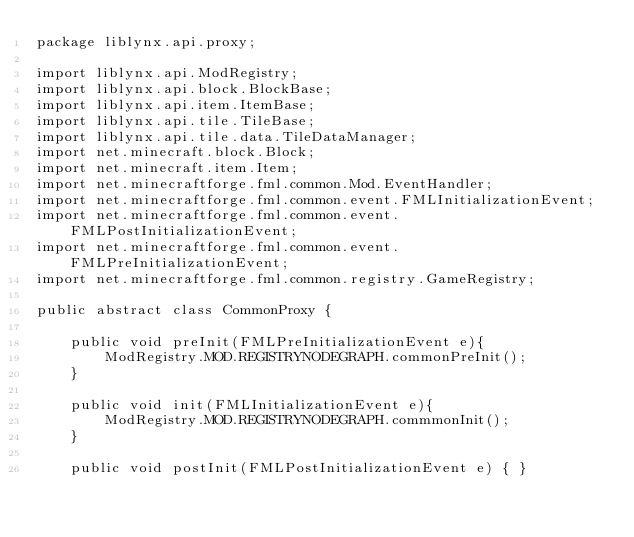Convert code to text. <code><loc_0><loc_0><loc_500><loc_500><_Java_>package liblynx.api.proxy;

import liblynx.api.ModRegistry;
import liblynx.api.block.BlockBase;
import liblynx.api.item.ItemBase;
import liblynx.api.tile.TileBase;
import liblynx.api.tile.data.TileDataManager;
import net.minecraft.block.Block;
import net.minecraft.item.Item;
import net.minecraftforge.fml.common.Mod.EventHandler;
import net.minecraftforge.fml.common.event.FMLInitializationEvent;
import net.minecraftforge.fml.common.event.FMLPostInitializationEvent;
import net.minecraftforge.fml.common.event.FMLPreInitializationEvent;
import net.minecraftforge.fml.common.registry.GameRegistry;

public abstract class CommonProxy {

    public void preInit(FMLPreInitializationEvent e){
        ModRegistry.MOD.REGISTRYNODEGRAPH.commonPreInit();
    }

    public void init(FMLInitializationEvent e){
        ModRegistry.MOD.REGISTRYNODEGRAPH.commmonInit();
    }

    public void postInit(FMLPostInitializationEvent e) { }
</code> 